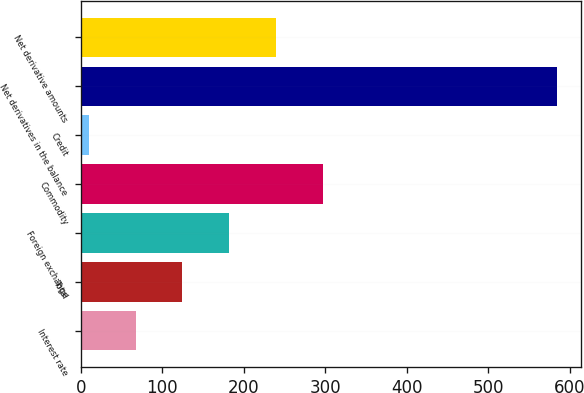<chart> <loc_0><loc_0><loc_500><loc_500><bar_chart><fcel>Interest rate<fcel>Total<fcel>Foreign exchange<fcel>Commodity<fcel>Credit<fcel>Net derivatives in the balance<fcel>Net derivative amounts<nl><fcel>67.4<fcel>124.8<fcel>182.2<fcel>297<fcel>10<fcel>584<fcel>239.6<nl></chart> 